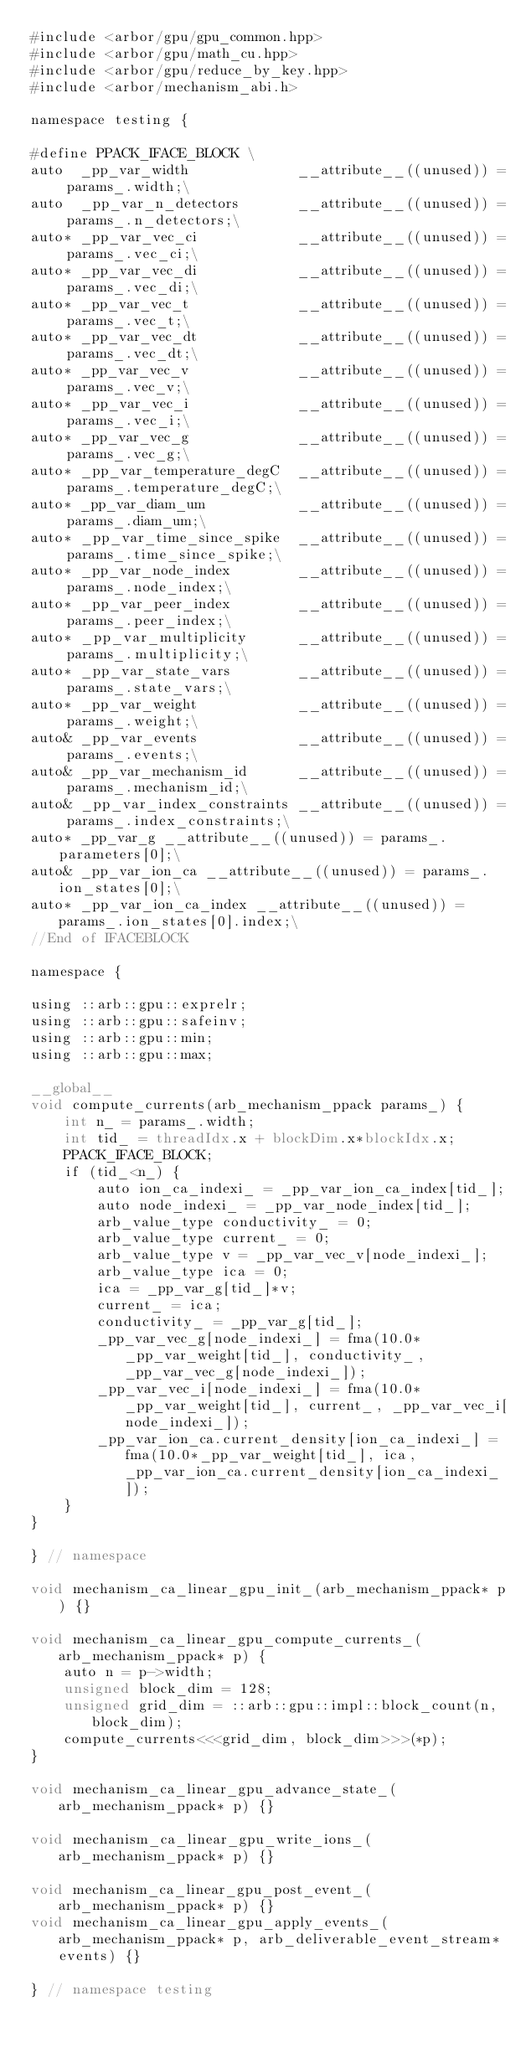<code> <loc_0><loc_0><loc_500><loc_500><_Cuda_>#include <arbor/gpu/gpu_common.hpp>
#include <arbor/gpu/math_cu.hpp>
#include <arbor/gpu/reduce_by_key.hpp>
#include <arbor/mechanism_abi.h>

namespace testing {

#define PPACK_IFACE_BLOCK \
auto  _pp_var_width             __attribute__((unused)) = params_.width;\
auto  _pp_var_n_detectors       __attribute__((unused)) = params_.n_detectors;\
auto* _pp_var_vec_ci            __attribute__((unused)) = params_.vec_ci;\
auto* _pp_var_vec_di            __attribute__((unused)) = params_.vec_di;\
auto* _pp_var_vec_t             __attribute__((unused)) = params_.vec_t;\
auto* _pp_var_vec_dt            __attribute__((unused)) = params_.vec_dt;\
auto* _pp_var_vec_v             __attribute__((unused)) = params_.vec_v;\
auto* _pp_var_vec_i             __attribute__((unused)) = params_.vec_i;\
auto* _pp_var_vec_g             __attribute__((unused)) = params_.vec_g;\
auto* _pp_var_temperature_degC  __attribute__((unused)) = params_.temperature_degC;\
auto* _pp_var_diam_um           __attribute__((unused)) = params_.diam_um;\
auto* _pp_var_time_since_spike  __attribute__((unused)) = params_.time_since_spike;\
auto* _pp_var_node_index        __attribute__((unused)) = params_.node_index;\
auto* _pp_var_peer_index        __attribute__((unused)) = params_.peer_index;\
auto* _pp_var_multiplicity      __attribute__((unused)) = params_.multiplicity;\
auto* _pp_var_state_vars        __attribute__((unused)) = params_.state_vars;\
auto* _pp_var_weight            __attribute__((unused)) = params_.weight;\
auto& _pp_var_events            __attribute__((unused)) = params_.events;\
auto& _pp_var_mechanism_id      __attribute__((unused)) = params_.mechanism_id;\
auto& _pp_var_index_constraints __attribute__((unused)) = params_.index_constraints;\
auto* _pp_var_g __attribute__((unused)) = params_.parameters[0];\
auto& _pp_var_ion_ca __attribute__((unused)) = params_.ion_states[0];\
auto* _pp_var_ion_ca_index __attribute__((unused)) = params_.ion_states[0].index;\
//End of IFACEBLOCK

namespace {

using ::arb::gpu::exprelr;
using ::arb::gpu::safeinv;
using ::arb::gpu::min;
using ::arb::gpu::max;

__global__
void compute_currents(arb_mechanism_ppack params_) {
    int n_ = params_.width;
    int tid_ = threadIdx.x + blockDim.x*blockIdx.x;
    PPACK_IFACE_BLOCK;
    if (tid_<n_) {
        auto ion_ca_indexi_ = _pp_var_ion_ca_index[tid_];
        auto node_indexi_ = _pp_var_node_index[tid_];
        arb_value_type conductivity_ = 0;
        arb_value_type current_ = 0;
        arb_value_type v = _pp_var_vec_v[node_indexi_];
        arb_value_type ica = 0;
        ica = _pp_var_g[tid_]*v;
        current_ = ica;
        conductivity_ = _pp_var_g[tid_];
        _pp_var_vec_g[node_indexi_] = fma(10.0*_pp_var_weight[tid_], conductivity_, _pp_var_vec_g[node_indexi_]);
        _pp_var_vec_i[node_indexi_] = fma(10.0*_pp_var_weight[tid_], current_, _pp_var_vec_i[node_indexi_]);
        _pp_var_ion_ca.current_density[ion_ca_indexi_] = fma(10.0*_pp_var_weight[tid_], ica, _pp_var_ion_ca.current_density[ion_ca_indexi_]);
    }
}

} // namespace

void mechanism_ca_linear_gpu_init_(arb_mechanism_ppack* p) {}

void mechanism_ca_linear_gpu_compute_currents_(arb_mechanism_ppack* p) {
    auto n = p->width;
    unsigned block_dim = 128;
    unsigned grid_dim = ::arb::gpu::impl::block_count(n, block_dim);
    compute_currents<<<grid_dim, block_dim>>>(*p);
}

void mechanism_ca_linear_gpu_advance_state_(arb_mechanism_ppack* p) {}

void mechanism_ca_linear_gpu_write_ions_(arb_mechanism_ppack* p) {}

void mechanism_ca_linear_gpu_post_event_(arb_mechanism_ppack* p) {}
void mechanism_ca_linear_gpu_apply_events_(arb_mechanism_ppack* p, arb_deliverable_event_stream* events) {}

} // namespace testing
</code> 